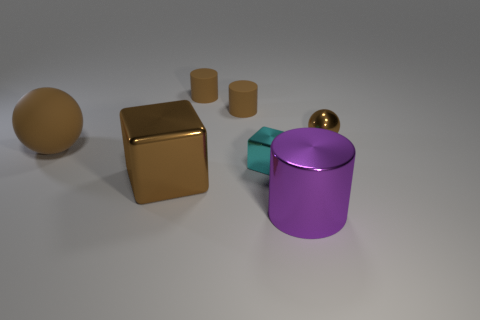Add 3 brown shiny spheres. How many objects exist? 10 Subtract all blocks. How many objects are left? 5 Add 6 big brown rubber spheres. How many big brown rubber spheres are left? 7 Add 7 cyan cubes. How many cyan cubes exist? 8 Subtract 0 green cylinders. How many objects are left? 7 Subtract all tiny matte things. Subtract all tiny objects. How many objects are left? 1 